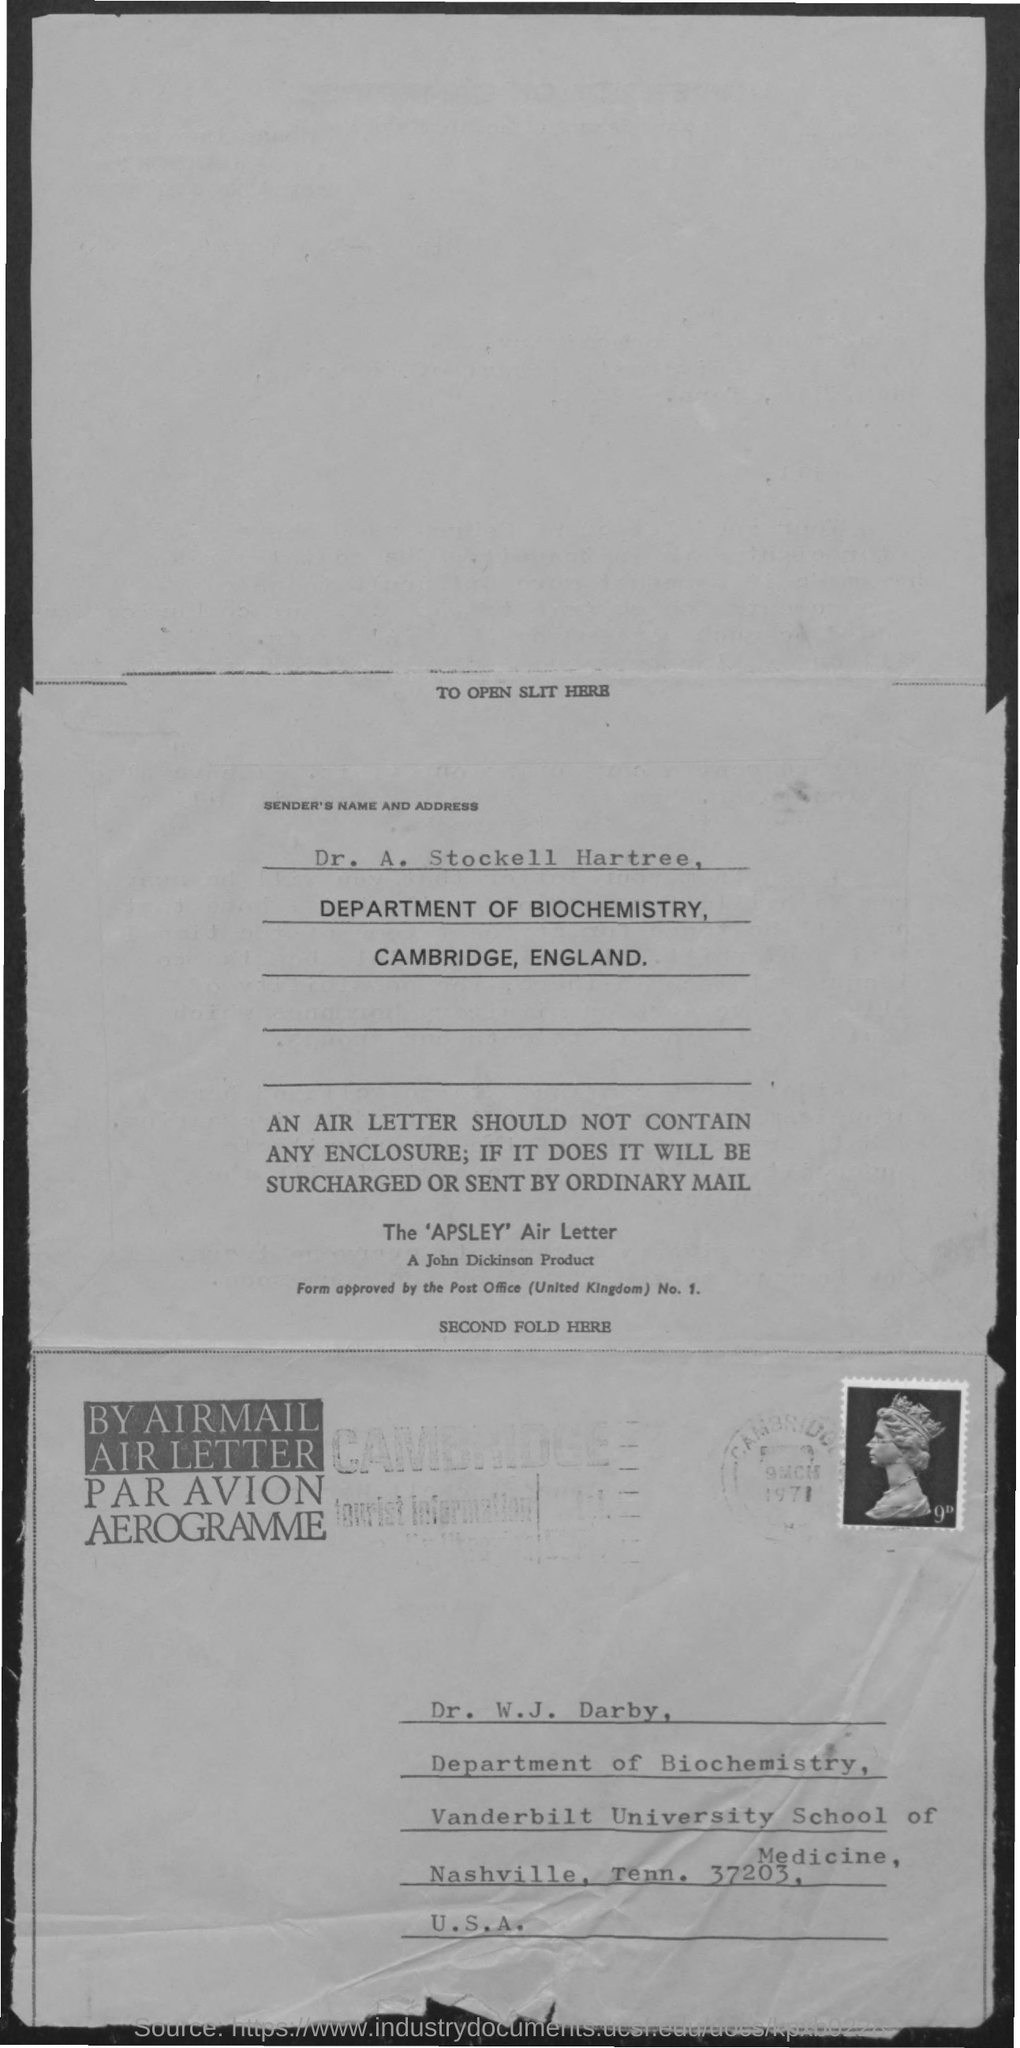Point out several critical features in this image. Dr. A. Stockell Hartree is a member of the Department of Biochemistry. The name of the sender is Dr. A. Stockell Hartree. 